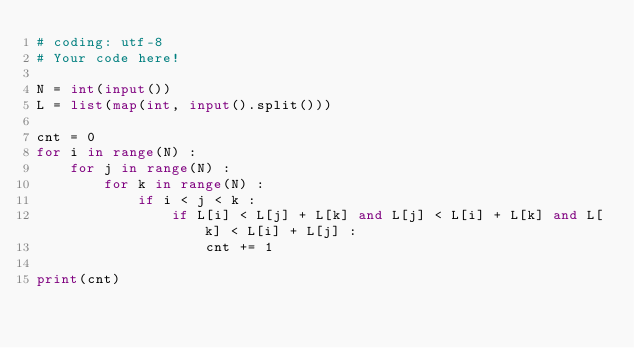<code> <loc_0><loc_0><loc_500><loc_500><_Python_># coding: utf-8
# Your code here!

N = int(input())
L = list(map(int, input().split()))

cnt = 0
for i in range(N) : 
    for j in range(N) : 
        for k in range(N) : 
            if i < j < k : 
                if L[i] < L[j] + L[k] and L[j] < L[i] + L[k] and L[k] < L[i] + L[j] : 
                    cnt += 1

print(cnt)</code> 